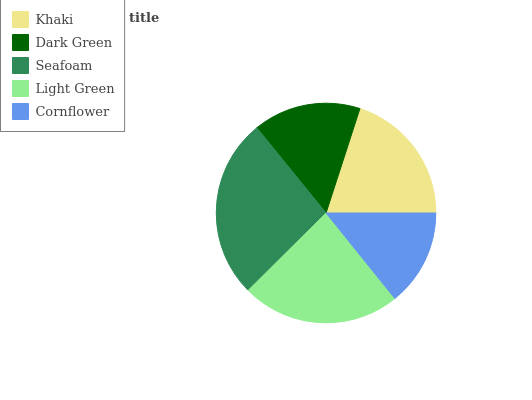Is Cornflower the minimum?
Answer yes or no. Yes. Is Seafoam the maximum?
Answer yes or no. Yes. Is Dark Green the minimum?
Answer yes or no. No. Is Dark Green the maximum?
Answer yes or no. No. Is Khaki greater than Dark Green?
Answer yes or no. Yes. Is Dark Green less than Khaki?
Answer yes or no. Yes. Is Dark Green greater than Khaki?
Answer yes or no. No. Is Khaki less than Dark Green?
Answer yes or no. No. Is Khaki the high median?
Answer yes or no. Yes. Is Khaki the low median?
Answer yes or no. Yes. Is Dark Green the high median?
Answer yes or no. No. Is Dark Green the low median?
Answer yes or no. No. 